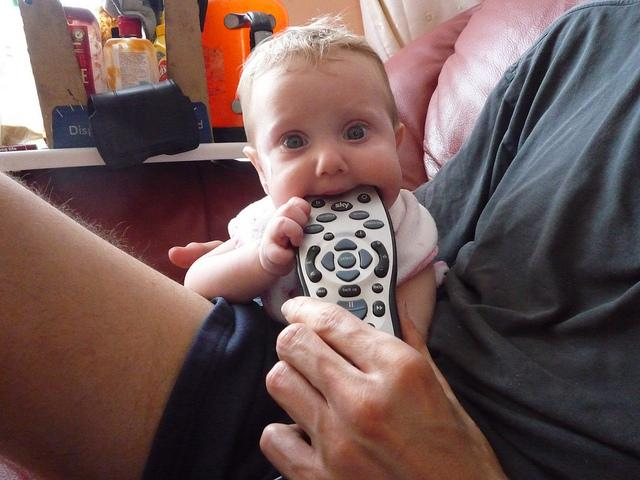What is the baby attempting to eat?

Choices:
A) big toe
B) remote control
C) apple slices
D) hot dog remote control 